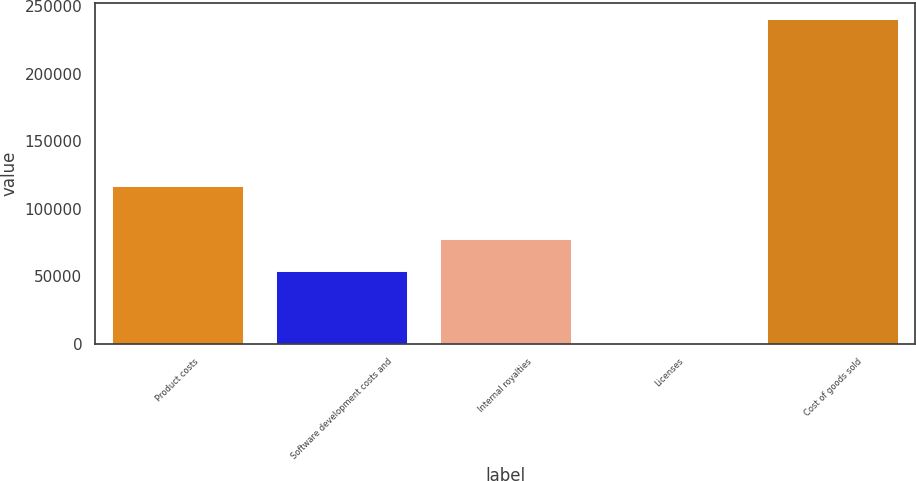Convert chart. <chart><loc_0><loc_0><loc_500><loc_500><bar_chart><fcel>Product costs<fcel>Software development costs and<fcel>Internal royalties<fcel>Licenses<fcel>Cost of goods sold<nl><fcel>116583<fcel>53438<fcel>77428.1<fcel>334<fcel>240235<nl></chart> 